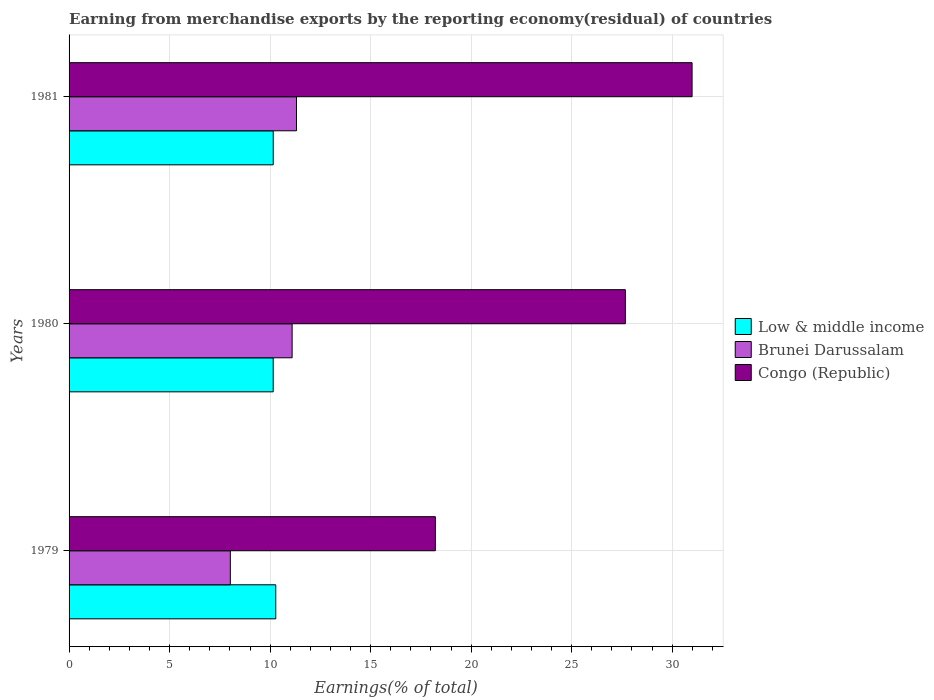How many groups of bars are there?
Your answer should be compact. 3. Are the number of bars on each tick of the Y-axis equal?
Your response must be concise. Yes. How many bars are there on the 2nd tick from the top?
Give a very brief answer. 3. What is the label of the 2nd group of bars from the top?
Give a very brief answer. 1980. In how many cases, is the number of bars for a given year not equal to the number of legend labels?
Offer a very short reply. 0. What is the percentage of amount earned from merchandise exports in Low & middle income in 1981?
Give a very brief answer. 10.16. Across all years, what is the maximum percentage of amount earned from merchandise exports in Low & middle income?
Ensure brevity in your answer.  10.28. Across all years, what is the minimum percentage of amount earned from merchandise exports in Low & middle income?
Provide a short and direct response. 10.15. What is the total percentage of amount earned from merchandise exports in Brunei Darussalam in the graph?
Provide a short and direct response. 30.43. What is the difference between the percentage of amount earned from merchandise exports in Low & middle income in 1979 and that in 1981?
Your response must be concise. 0.13. What is the difference between the percentage of amount earned from merchandise exports in Low & middle income in 1981 and the percentage of amount earned from merchandise exports in Congo (Republic) in 1980?
Offer a very short reply. -17.52. What is the average percentage of amount earned from merchandise exports in Brunei Darussalam per year?
Offer a terse response. 10.14. In the year 1981, what is the difference between the percentage of amount earned from merchandise exports in Congo (Republic) and percentage of amount earned from merchandise exports in Brunei Darussalam?
Ensure brevity in your answer.  19.68. What is the ratio of the percentage of amount earned from merchandise exports in Brunei Darussalam in 1979 to that in 1981?
Ensure brevity in your answer.  0.71. Is the percentage of amount earned from merchandise exports in Congo (Republic) in 1979 less than that in 1981?
Give a very brief answer. Yes. What is the difference between the highest and the second highest percentage of amount earned from merchandise exports in Low & middle income?
Offer a very short reply. 0.13. What is the difference between the highest and the lowest percentage of amount earned from merchandise exports in Brunei Darussalam?
Ensure brevity in your answer.  3.29. In how many years, is the percentage of amount earned from merchandise exports in Congo (Republic) greater than the average percentage of amount earned from merchandise exports in Congo (Republic) taken over all years?
Make the answer very short. 2. Is the sum of the percentage of amount earned from merchandise exports in Low & middle income in 1980 and 1981 greater than the maximum percentage of amount earned from merchandise exports in Brunei Darussalam across all years?
Keep it short and to the point. Yes. What does the 2nd bar from the top in 1980 represents?
Make the answer very short. Brunei Darussalam. What does the 2nd bar from the bottom in 1979 represents?
Your answer should be compact. Brunei Darussalam. How many bars are there?
Your response must be concise. 9. Are all the bars in the graph horizontal?
Give a very brief answer. Yes. How many years are there in the graph?
Ensure brevity in your answer.  3. What is the difference between two consecutive major ticks on the X-axis?
Provide a short and direct response. 5. Are the values on the major ticks of X-axis written in scientific E-notation?
Make the answer very short. No. Does the graph contain any zero values?
Ensure brevity in your answer.  No. How are the legend labels stacked?
Your response must be concise. Vertical. What is the title of the graph?
Provide a succinct answer. Earning from merchandise exports by the reporting economy(residual) of countries. What is the label or title of the X-axis?
Your response must be concise. Earnings(% of total). What is the label or title of the Y-axis?
Ensure brevity in your answer.  Years. What is the Earnings(% of total) of Low & middle income in 1979?
Provide a succinct answer. 10.28. What is the Earnings(% of total) in Brunei Darussalam in 1979?
Ensure brevity in your answer.  8.02. What is the Earnings(% of total) in Congo (Republic) in 1979?
Your response must be concise. 18.22. What is the Earnings(% of total) in Low & middle income in 1980?
Provide a short and direct response. 10.15. What is the Earnings(% of total) in Brunei Darussalam in 1980?
Provide a succinct answer. 11.1. What is the Earnings(% of total) of Congo (Republic) in 1980?
Give a very brief answer. 27.67. What is the Earnings(% of total) of Low & middle income in 1981?
Keep it short and to the point. 10.16. What is the Earnings(% of total) of Brunei Darussalam in 1981?
Your response must be concise. 11.31. What is the Earnings(% of total) of Congo (Republic) in 1981?
Your answer should be very brief. 30.99. Across all years, what is the maximum Earnings(% of total) in Low & middle income?
Give a very brief answer. 10.28. Across all years, what is the maximum Earnings(% of total) of Brunei Darussalam?
Your response must be concise. 11.31. Across all years, what is the maximum Earnings(% of total) of Congo (Republic)?
Your answer should be compact. 30.99. Across all years, what is the minimum Earnings(% of total) of Low & middle income?
Your answer should be compact. 10.15. Across all years, what is the minimum Earnings(% of total) in Brunei Darussalam?
Give a very brief answer. 8.02. Across all years, what is the minimum Earnings(% of total) in Congo (Republic)?
Offer a very short reply. 18.22. What is the total Earnings(% of total) in Low & middle income in the graph?
Keep it short and to the point. 30.59. What is the total Earnings(% of total) in Brunei Darussalam in the graph?
Give a very brief answer. 30.43. What is the total Earnings(% of total) of Congo (Republic) in the graph?
Offer a terse response. 76.88. What is the difference between the Earnings(% of total) of Low & middle income in 1979 and that in 1980?
Offer a very short reply. 0.13. What is the difference between the Earnings(% of total) in Brunei Darussalam in 1979 and that in 1980?
Your response must be concise. -3.07. What is the difference between the Earnings(% of total) in Congo (Republic) in 1979 and that in 1980?
Give a very brief answer. -9.45. What is the difference between the Earnings(% of total) in Low & middle income in 1979 and that in 1981?
Offer a terse response. 0.13. What is the difference between the Earnings(% of total) of Brunei Darussalam in 1979 and that in 1981?
Provide a succinct answer. -3.29. What is the difference between the Earnings(% of total) in Congo (Republic) in 1979 and that in 1981?
Give a very brief answer. -12.77. What is the difference between the Earnings(% of total) in Low & middle income in 1980 and that in 1981?
Give a very brief answer. -0. What is the difference between the Earnings(% of total) of Brunei Darussalam in 1980 and that in 1981?
Provide a short and direct response. -0.22. What is the difference between the Earnings(% of total) of Congo (Republic) in 1980 and that in 1981?
Offer a very short reply. -3.32. What is the difference between the Earnings(% of total) in Low & middle income in 1979 and the Earnings(% of total) in Brunei Darussalam in 1980?
Provide a short and direct response. -0.81. What is the difference between the Earnings(% of total) in Low & middle income in 1979 and the Earnings(% of total) in Congo (Republic) in 1980?
Ensure brevity in your answer.  -17.39. What is the difference between the Earnings(% of total) of Brunei Darussalam in 1979 and the Earnings(% of total) of Congo (Republic) in 1980?
Your response must be concise. -19.65. What is the difference between the Earnings(% of total) of Low & middle income in 1979 and the Earnings(% of total) of Brunei Darussalam in 1981?
Give a very brief answer. -1.03. What is the difference between the Earnings(% of total) in Low & middle income in 1979 and the Earnings(% of total) in Congo (Republic) in 1981?
Keep it short and to the point. -20.71. What is the difference between the Earnings(% of total) of Brunei Darussalam in 1979 and the Earnings(% of total) of Congo (Republic) in 1981?
Ensure brevity in your answer.  -22.97. What is the difference between the Earnings(% of total) of Low & middle income in 1980 and the Earnings(% of total) of Brunei Darussalam in 1981?
Your answer should be very brief. -1.16. What is the difference between the Earnings(% of total) in Low & middle income in 1980 and the Earnings(% of total) in Congo (Republic) in 1981?
Your answer should be compact. -20.84. What is the difference between the Earnings(% of total) in Brunei Darussalam in 1980 and the Earnings(% of total) in Congo (Republic) in 1981?
Ensure brevity in your answer.  -19.9. What is the average Earnings(% of total) of Low & middle income per year?
Provide a succinct answer. 10.2. What is the average Earnings(% of total) of Brunei Darussalam per year?
Offer a terse response. 10.14. What is the average Earnings(% of total) in Congo (Republic) per year?
Your response must be concise. 25.63. In the year 1979, what is the difference between the Earnings(% of total) in Low & middle income and Earnings(% of total) in Brunei Darussalam?
Provide a short and direct response. 2.26. In the year 1979, what is the difference between the Earnings(% of total) of Low & middle income and Earnings(% of total) of Congo (Republic)?
Your answer should be very brief. -7.94. In the year 1979, what is the difference between the Earnings(% of total) of Brunei Darussalam and Earnings(% of total) of Congo (Republic)?
Your response must be concise. -10.2. In the year 1980, what is the difference between the Earnings(% of total) of Low & middle income and Earnings(% of total) of Brunei Darussalam?
Your response must be concise. -0.94. In the year 1980, what is the difference between the Earnings(% of total) in Low & middle income and Earnings(% of total) in Congo (Republic)?
Offer a very short reply. -17.52. In the year 1980, what is the difference between the Earnings(% of total) in Brunei Darussalam and Earnings(% of total) in Congo (Republic)?
Your response must be concise. -16.58. In the year 1981, what is the difference between the Earnings(% of total) in Low & middle income and Earnings(% of total) in Brunei Darussalam?
Provide a short and direct response. -1.16. In the year 1981, what is the difference between the Earnings(% of total) of Low & middle income and Earnings(% of total) of Congo (Republic)?
Your response must be concise. -20.84. In the year 1981, what is the difference between the Earnings(% of total) in Brunei Darussalam and Earnings(% of total) in Congo (Republic)?
Ensure brevity in your answer.  -19.68. What is the ratio of the Earnings(% of total) of Low & middle income in 1979 to that in 1980?
Make the answer very short. 1.01. What is the ratio of the Earnings(% of total) in Brunei Darussalam in 1979 to that in 1980?
Keep it short and to the point. 0.72. What is the ratio of the Earnings(% of total) of Congo (Republic) in 1979 to that in 1980?
Your answer should be compact. 0.66. What is the ratio of the Earnings(% of total) in Low & middle income in 1979 to that in 1981?
Make the answer very short. 1.01. What is the ratio of the Earnings(% of total) in Brunei Darussalam in 1979 to that in 1981?
Keep it short and to the point. 0.71. What is the ratio of the Earnings(% of total) in Congo (Republic) in 1979 to that in 1981?
Offer a terse response. 0.59. What is the ratio of the Earnings(% of total) in Low & middle income in 1980 to that in 1981?
Ensure brevity in your answer.  1. What is the ratio of the Earnings(% of total) in Brunei Darussalam in 1980 to that in 1981?
Make the answer very short. 0.98. What is the ratio of the Earnings(% of total) in Congo (Republic) in 1980 to that in 1981?
Make the answer very short. 0.89. What is the difference between the highest and the second highest Earnings(% of total) of Low & middle income?
Offer a very short reply. 0.13. What is the difference between the highest and the second highest Earnings(% of total) of Brunei Darussalam?
Ensure brevity in your answer.  0.22. What is the difference between the highest and the second highest Earnings(% of total) in Congo (Republic)?
Your answer should be compact. 3.32. What is the difference between the highest and the lowest Earnings(% of total) of Low & middle income?
Make the answer very short. 0.13. What is the difference between the highest and the lowest Earnings(% of total) in Brunei Darussalam?
Offer a terse response. 3.29. What is the difference between the highest and the lowest Earnings(% of total) in Congo (Republic)?
Make the answer very short. 12.77. 